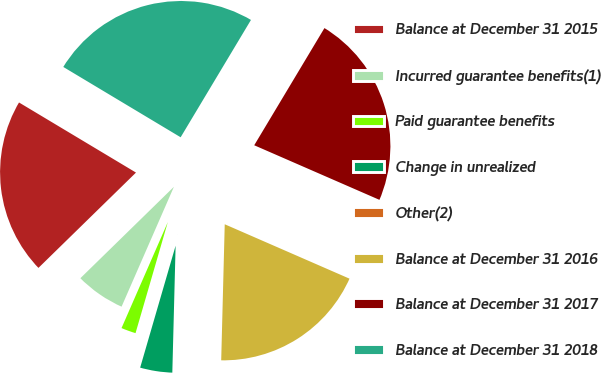Convert chart. <chart><loc_0><loc_0><loc_500><loc_500><pie_chart><fcel>Balance at December 31 2015<fcel>Incurred guarantee benefits(1)<fcel>Paid guarantee benefits<fcel>Change in unrealized<fcel>Other(2)<fcel>Balance at December 31 2016<fcel>Balance at December 31 2017<fcel>Balance at December 31 2018<nl><fcel>20.91%<fcel>6.13%<fcel>2.05%<fcel>4.09%<fcel>0.0%<fcel>18.87%<fcel>22.95%<fcel>25.0%<nl></chart> 